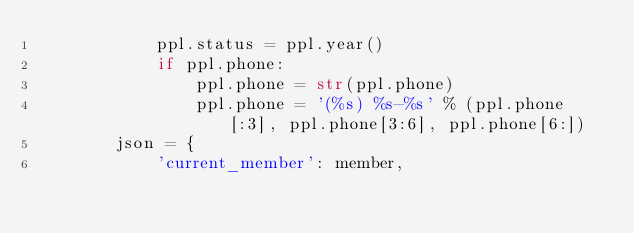<code> <loc_0><loc_0><loc_500><loc_500><_Python_>            ppl.status = ppl.year()
            if ppl.phone:
                ppl.phone = str(ppl.phone)
                ppl.phone = '(%s) %s-%s' % (ppl.phone[:3], ppl.phone[3:6], ppl.phone[6:])
        json = {
            'current_member': member,</code> 